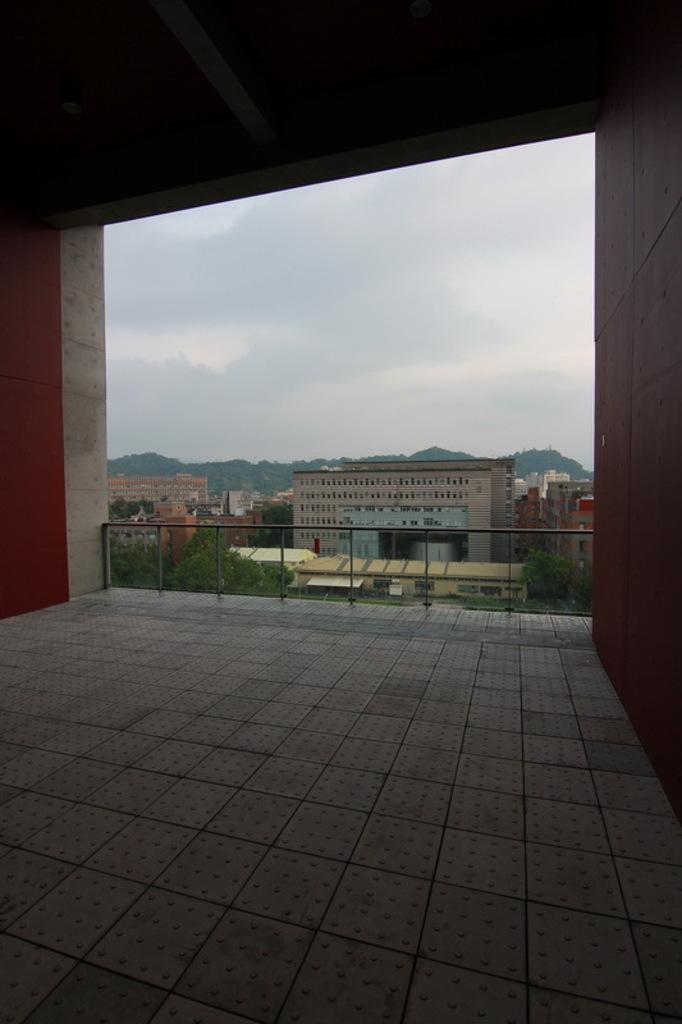What type of structure is shown in the image? The image is an inside view of a shed. What can be seen on the sides of the shed? There are walls on the right and left sides of the image. What is visible in the background of the image? There are buildings and trees in the background of the image. What is visible at the top of the image? The sky is visible at the top of the image. What type of car is parked on the throne in the image? There is no car or throne present in the image; it is an inside view of a shed with walls, background elements, and a visible sky. 